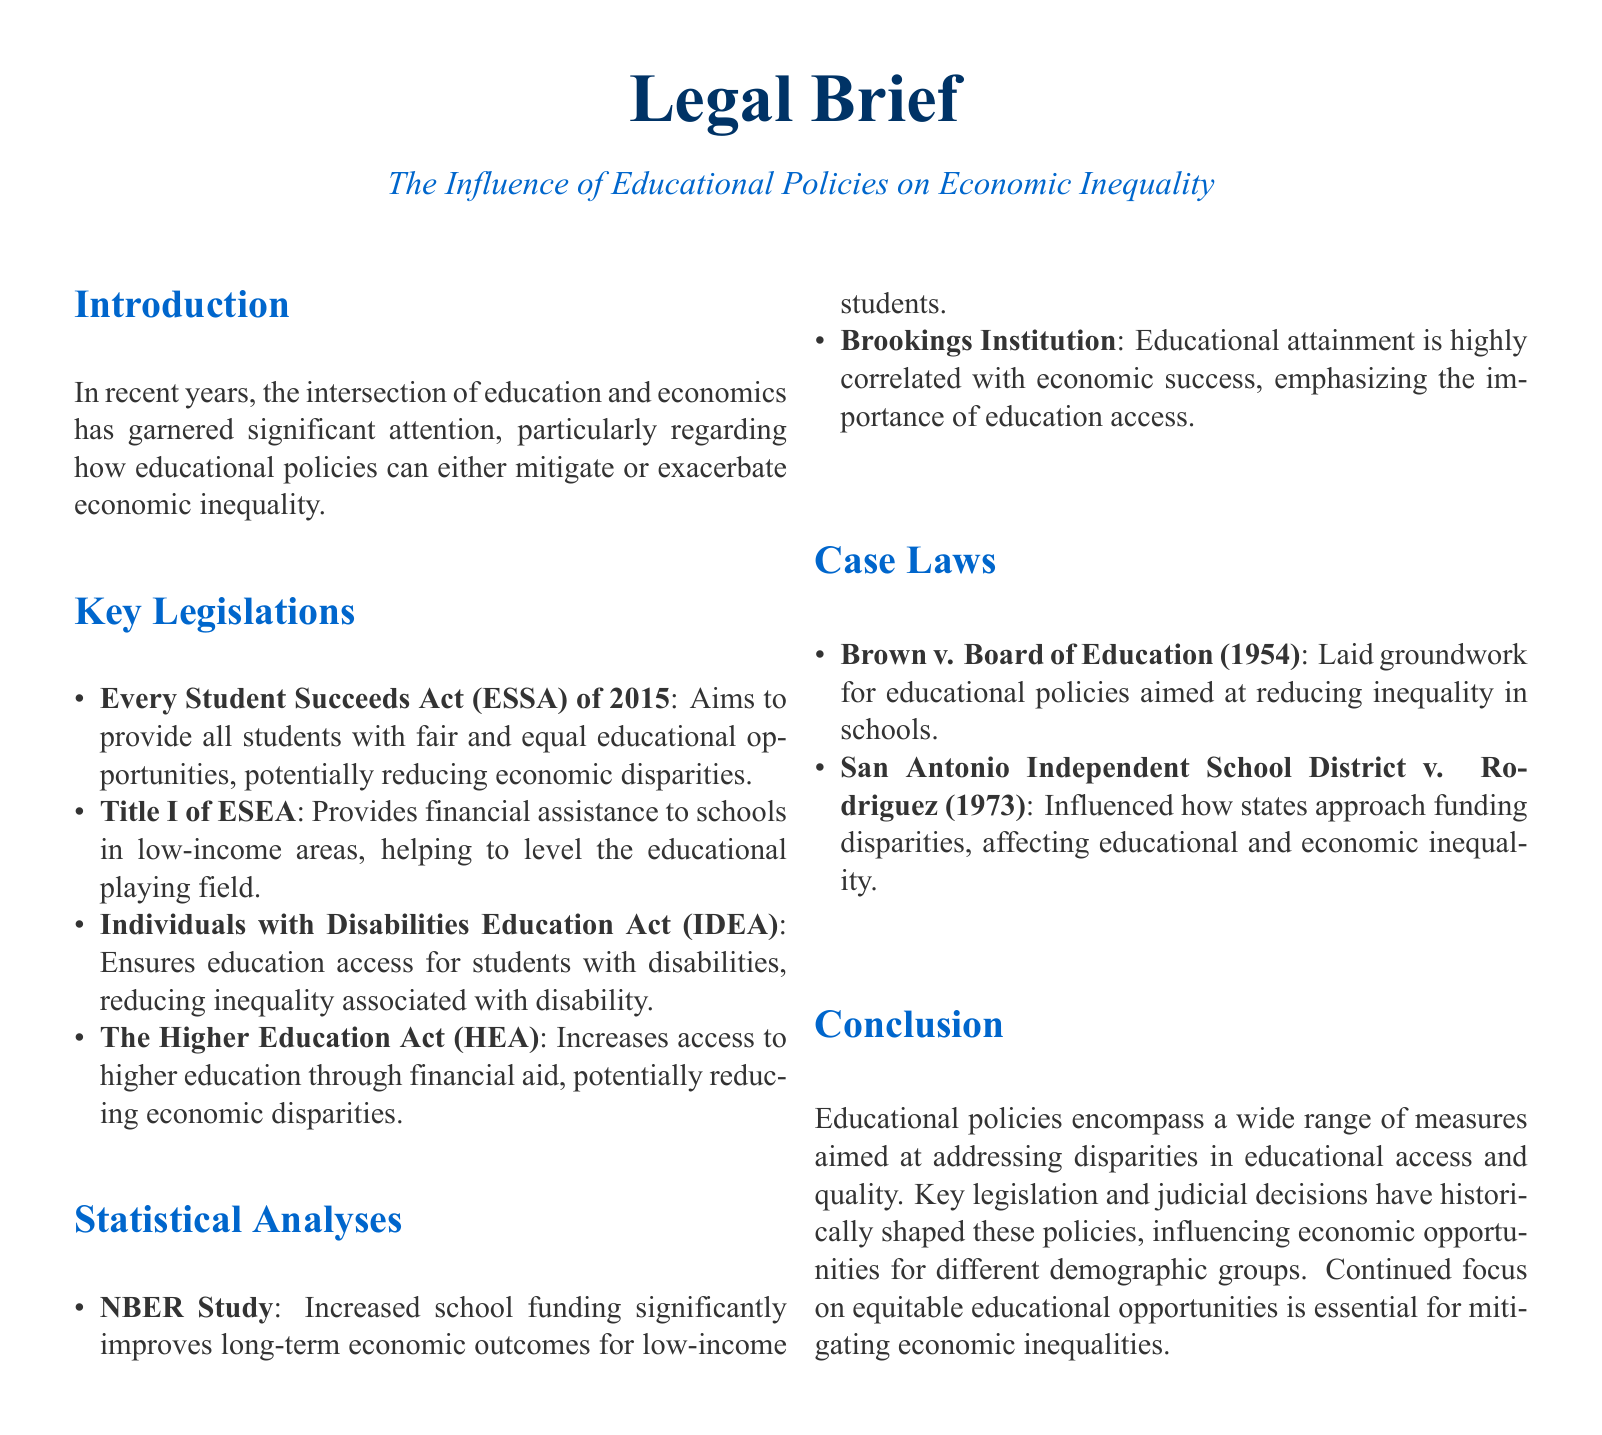What is the main focus of the legal brief? The main focus of the legal brief is on the intersection of education and economics, particularly how educational policies can influence economic inequality.
Answer: educational policies and economic inequality What year was the Every Student Succeeds Act enacted? The document specifies that the Every Student Succeeds Act was enacted in 2015.
Answer: 2015 Which case laid the groundwork for educational policies aimed at reducing inequality? The brief mentions Brown v. Board of Education (1954) as the case that laid the groundwork for educational policies aimed at reducing inequality.
Answer: Brown v. Board of Education What does Title I of ESEA provide? Title I of ESEA provides financial assistance to schools in low-income areas.
Answer: financial assistance According to the NBER Study, what does increased school funding improve? The document states that increased school funding significantly improves long-term economic outcomes for low-income students.
Answer: long-term economic outcomes How many key legislations are mentioned in the document? The document lists four key legislations that influence educational policies related to economic inequality.
Answer: four Which judicial decision influences state approaches to funding disparities? The decision that influences state approaches to funding disparities is San Antonio Independent School District v. Rodriguez (1973).
Answer: San Antonio Independent School District v. Rodriguez What is emphasized by the Brookings Institution regarding educational attainment? The Brookings Institution emphasizes that educational attainment is highly correlated with economic success.
Answer: economic success What is essential for mitigating economic inequalities, according to the conclusion? The conclusion states that continued focus on equitable educational opportunities is essential for mitigating economic inequalities.
Answer: equitable educational opportunities 